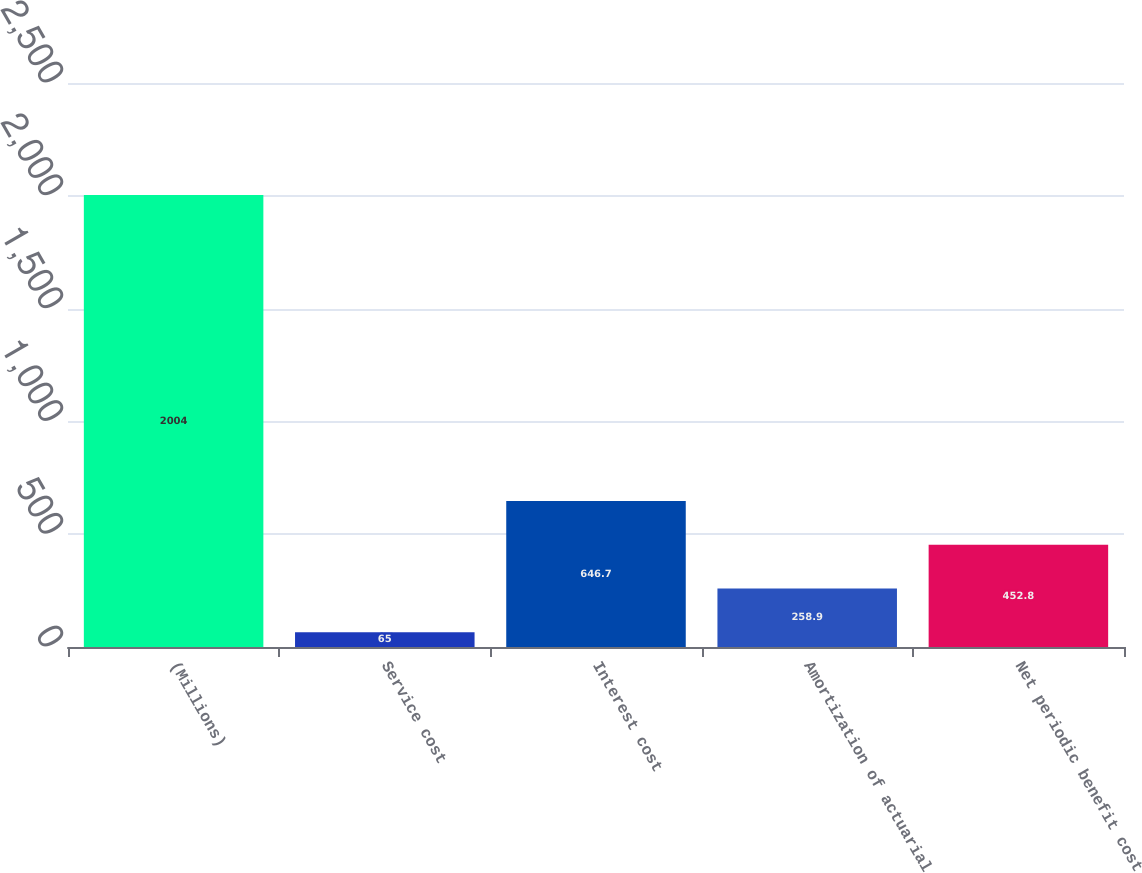Convert chart. <chart><loc_0><loc_0><loc_500><loc_500><bar_chart><fcel>(Millions)<fcel>Service cost<fcel>Interest cost<fcel>Amortization of actuarial<fcel>Net periodic benefit cost<nl><fcel>2004<fcel>65<fcel>646.7<fcel>258.9<fcel>452.8<nl></chart> 